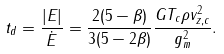<formula> <loc_0><loc_0><loc_500><loc_500>t _ { d } = \frac { | E | } { \dot { E } } = \frac { 2 ( 5 - \beta ) } { 3 ( 5 - 2 \beta ) } \frac { G T _ { c } \rho v _ { z , c } ^ { 2 } } { g _ { m } ^ { 2 } } .</formula> 